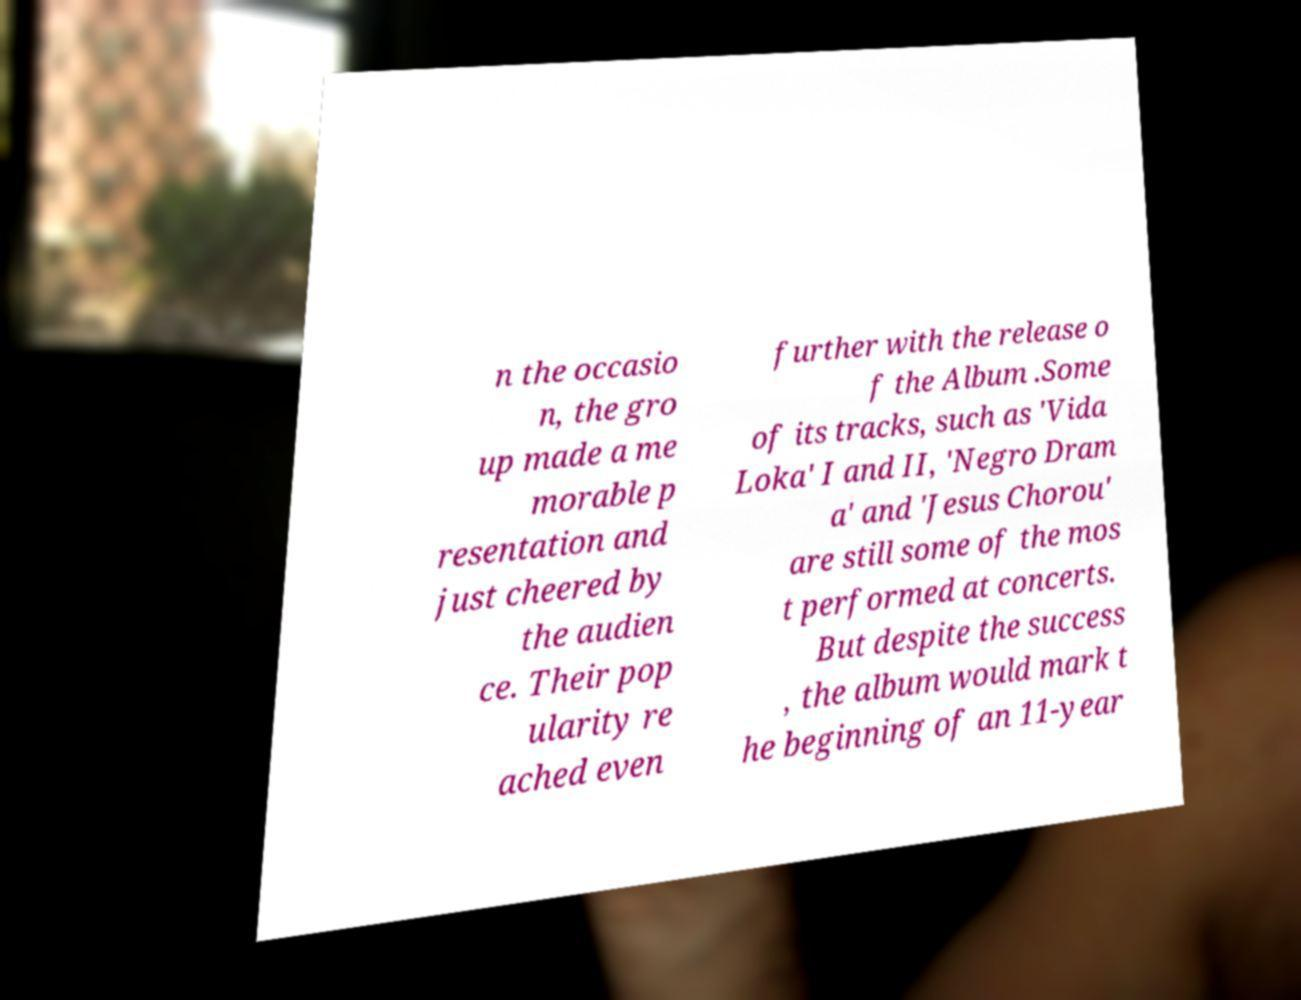What messages or text are displayed in this image? I need them in a readable, typed format. n the occasio n, the gro up made a me morable p resentation and just cheered by the audien ce. Their pop ularity re ached even further with the release o f the Album .Some of its tracks, such as 'Vida Loka' I and II, 'Negro Dram a' and 'Jesus Chorou' are still some of the mos t performed at concerts. But despite the success , the album would mark t he beginning of an 11-year 